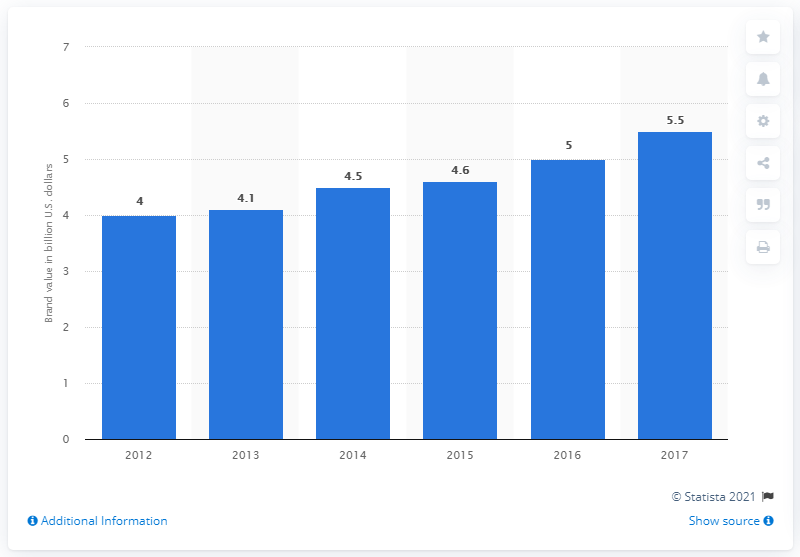Highlight a few significant elements in this photo. In 2017, the brand value of Sky Sports was estimated to be 5.5. 